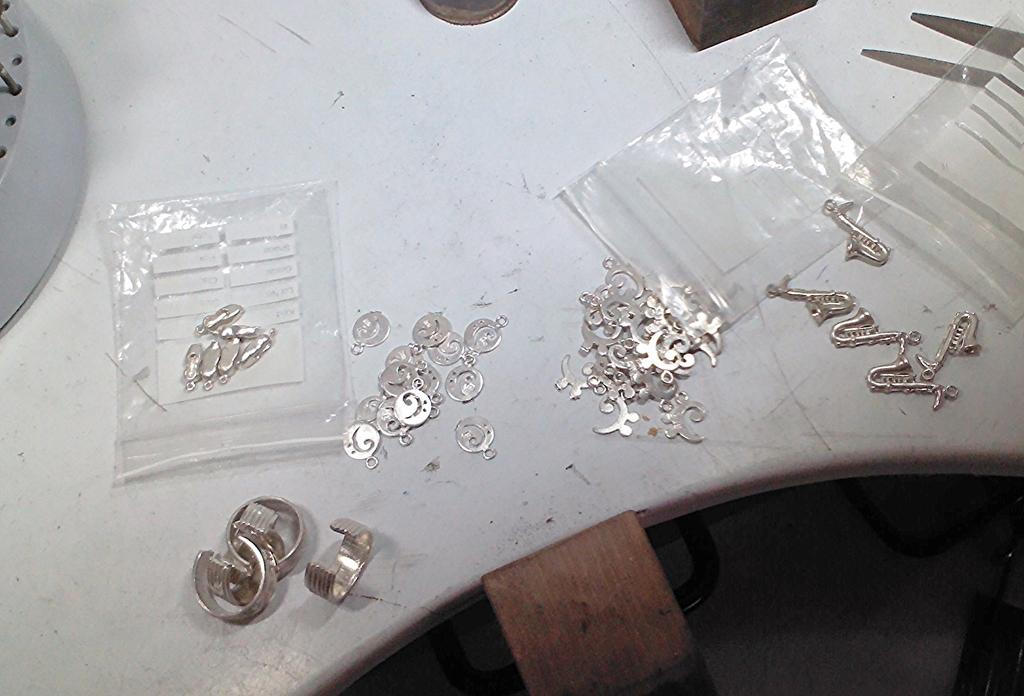What types of items are displayed on the table in the image? There are different models of pendants and covers in the image. Where are the pendants and covers located? They are placed on a table in the image. What can be seen on the left side of the image? There is an object on the left side of the image, which appears to be a wooden block. What type of jeans is the person wearing in the image? There is no person wearing jeans in the image; it features pendants, covers, and a wooden block on a table. How many toes can be seen in the image? There are no toes visible in the image. 